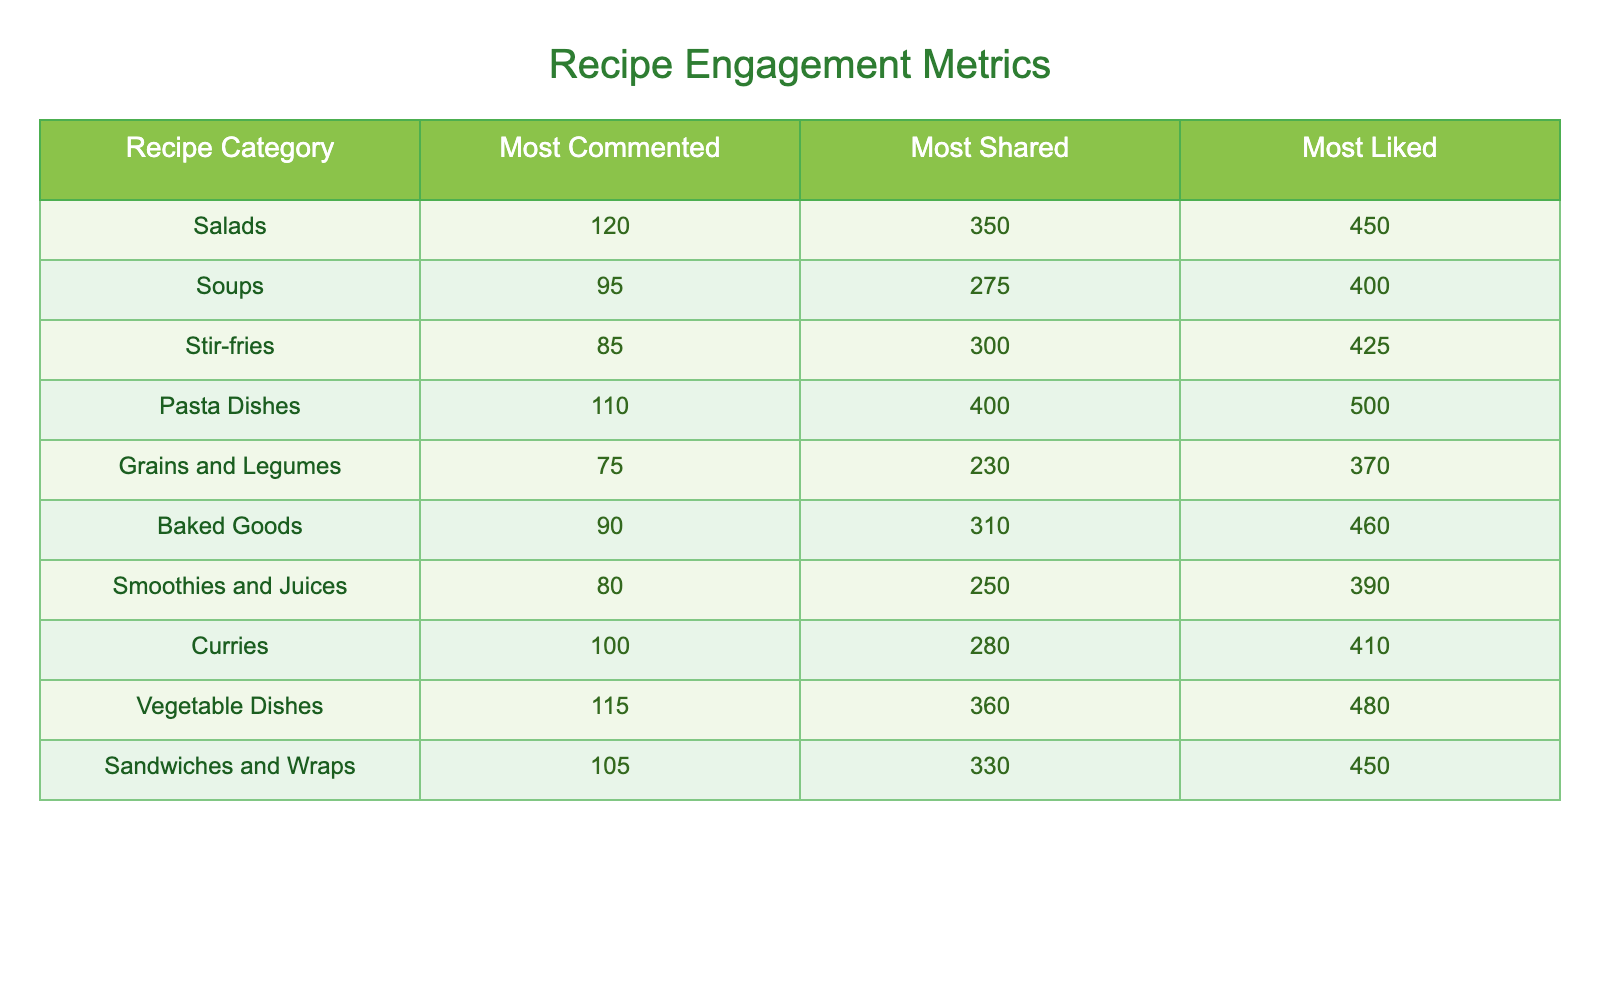What is the most liked recipe category? Referring to the "Most Liked" column, the highest number is 500, which corresponds to the "Pasta Dishes" category.
Answer: Pasta Dishes How many comments did the "Curries" category receive? Looking at the "Most Commented" column, the value for "Curries" is 100.
Answer: 100 Which category has the least number of shares? "Grains and Legumes" has the lowest value of 230 in the "Most Shared" column when compared to all other categories.
Answer: Grains and Legumes What's the total number of likes for Salads and Soups? For "Salads," the likes are 450 and for "Soups," it is 400. Adding these two gives us 450 + 400 = 850 likes in total.
Answer: 850 Is the number of shares for "Stir-fries" greater than that for "Vegetable Dishes"? Looking at the "Most Shared" column, "Stir-fries" has 300 shares while "Vegetable Dishes" has 360 shares; since 300 is less than 360, the statement is false.
Answer: No What is the average number of comments across all recipe categories? The total comments are calculated by adding all entries in the "Most Commented" column: 120 + 95 + 85 + 110 + 75 + 90 + 80 + 100 + 115 + 105 = 1,055. There are 10 categories, so the average is 1,055 / 10 = 105.5 comments.
Answer: 105.5 Which recipe category has a higher number of likes: "Baked Goods" or "Smoothies and Juices"? For "Baked Goods," there are 460 likes, and for "Smoothies and Juices," there are 390 likes. Comparing these values, 460 is greater than 390, thus "Baked Goods" has more likes.
Answer: Baked Goods Find the difference in the number of comments between "Salads" and "Grains and Legumes." "Salads" received 120 comments while "Grains and Legumes" received 75 comments. The difference is 120 - 75 = 45 comments.
Answer: 45 What is true about the "Pasta Dishes" regarding comments and shares? For "Pasta Dishes," there are 110 comments and 400 shares; the values indicate that it receives a fair amount of both comments and shares, thus supporting the hypothesis that it is popular among readers.
Answer: True 